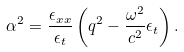Convert formula to latex. <formula><loc_0><loc_0><loc_500><loc_500>\alpha ^ { 2 } = \frac { \epsilon _ { x x } } { \epsilon _ { t } } \left ( q ^ { 2 } - \frac { \omega ^ { 2 } } { c ^ { 2 } } \epsilon _ { t } \right ) .</formula> 